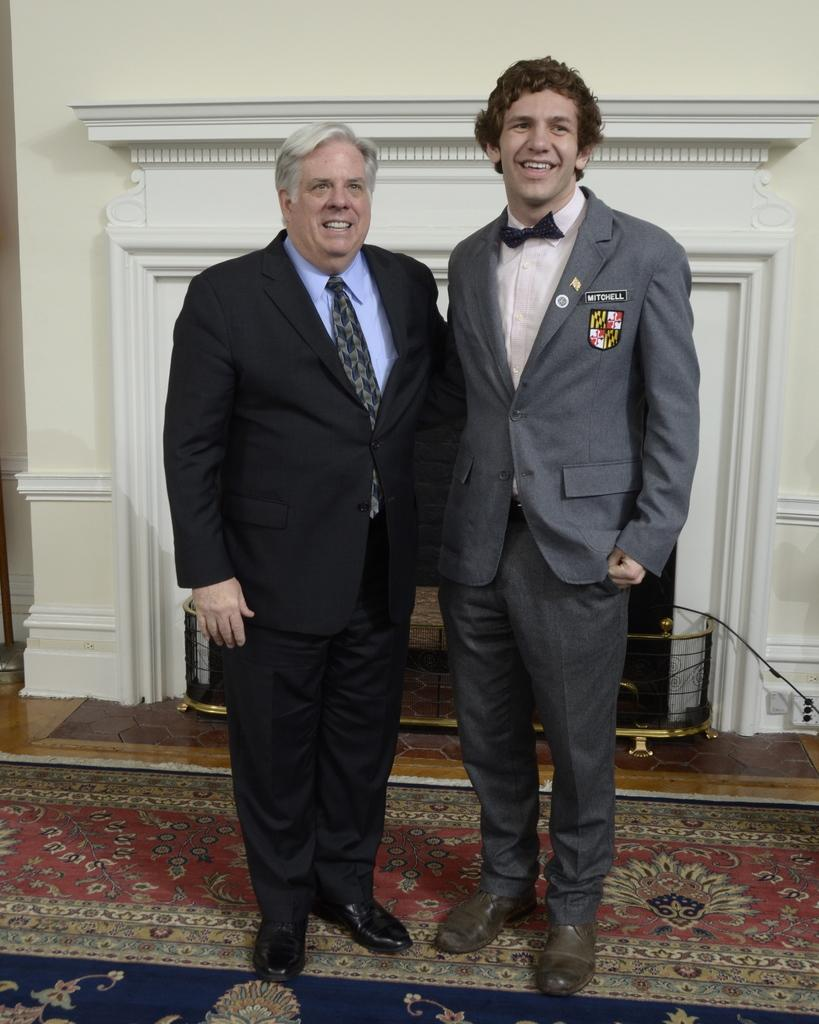How many people are in the image? There are two men in the image. What are the men doing in the image? The men are standing on a carpet and smiling. What can be seen in the background of the image? There is a wall, a grille, and other objects in the background of the image. What type of surface is visible under the men's feet? There is a floor visible in the image. What type of weather is depicted in the image? The image does not depict any weather conditions; it is an indoor scene with two men standing on a carpet. What type of feast is being prepared in the image? There is no feast or preparation for a feast visible in the image. 